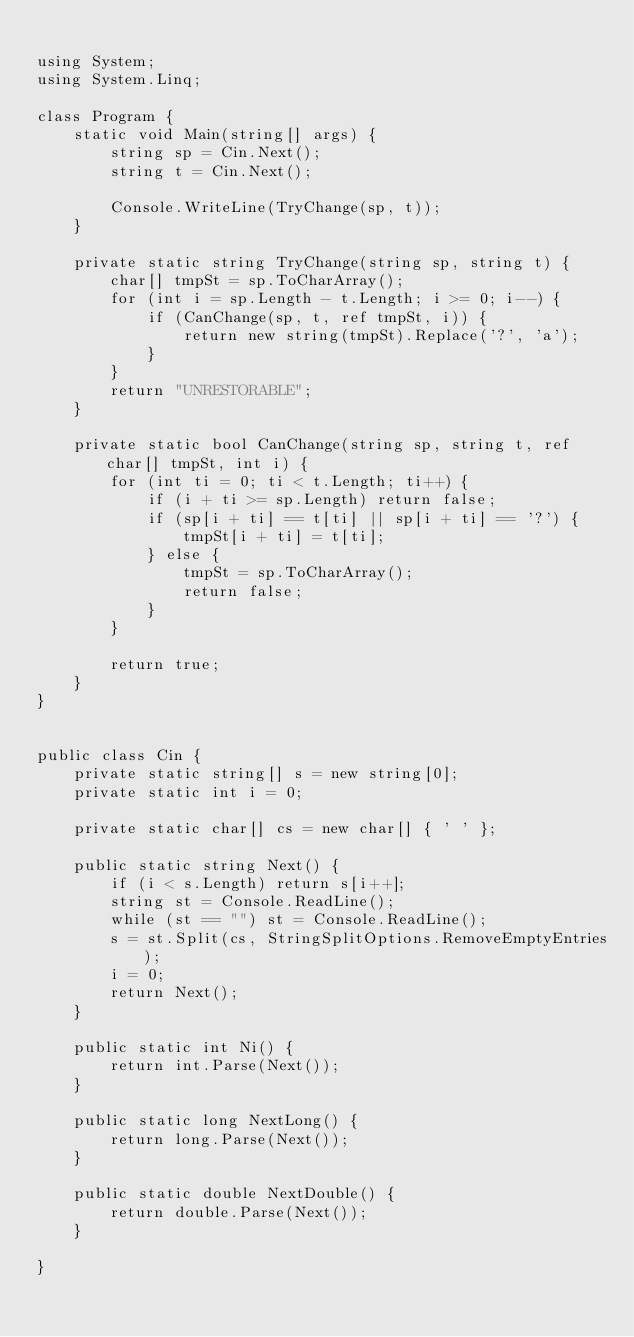<code> <loc_0><loc_0><loc_500><loc_500><_C#_>
using System;
using System.Linq;

class Program {
    static void Main(string[] args) {
        string sp = Cin.Next();
        string t = Cin.Next();

        Console.WriteLine(TryChange(sp, t));
    }

    private static string TryChange(string sp, string t) {
        char[] tmpSt = sp.ToCharArray();
        for (int i = sp.Length - t.Length; i >= 0; i--) {
            if (CanChange(sp, t, ref tmpSt, i)) {
                return new string(tmpSt).Replace('?', 'a');
            }
        }
        return "UNRESTORABLE";
    }

    private static bool CanChange(string sp, string t, ref char[] tmpSt, int i) {
        for (int ti = 0; ti < t.Length; ti++) {
            if (i + ti >= sp.Length) return false;
            if (sp[i + ti] == t[ti] || sp[i + ti] == '?') {
                tmpSt[i + ti] = t[ti];
            } else {
                tmpSt = sp.ToCharArray();
                return false;
            }
        }

        return true;
    }
}


public class Cin {
    private static string[] s = new string[0];
    private static int i = 0;

    private static char[] cs = new char[] { ' ' };

    public static string Next() {
        if (i < s.Length) return s[i++];
        string st = Console.ReadLine();
        while (st == "") st = Console.ReadLine();
        s = st.Split(cs, StringSplitOptions.RemoveEmptyEntries);
        i = 0;
        return Next();
    }

    public static int Ni() {
        return int.Parse(Next());
    }

    public static long NextLong() {
        return long.Parse(Next());
    }

    public static double NextDouble() {
        return double.Parse(Next());
    }

}
</code> 